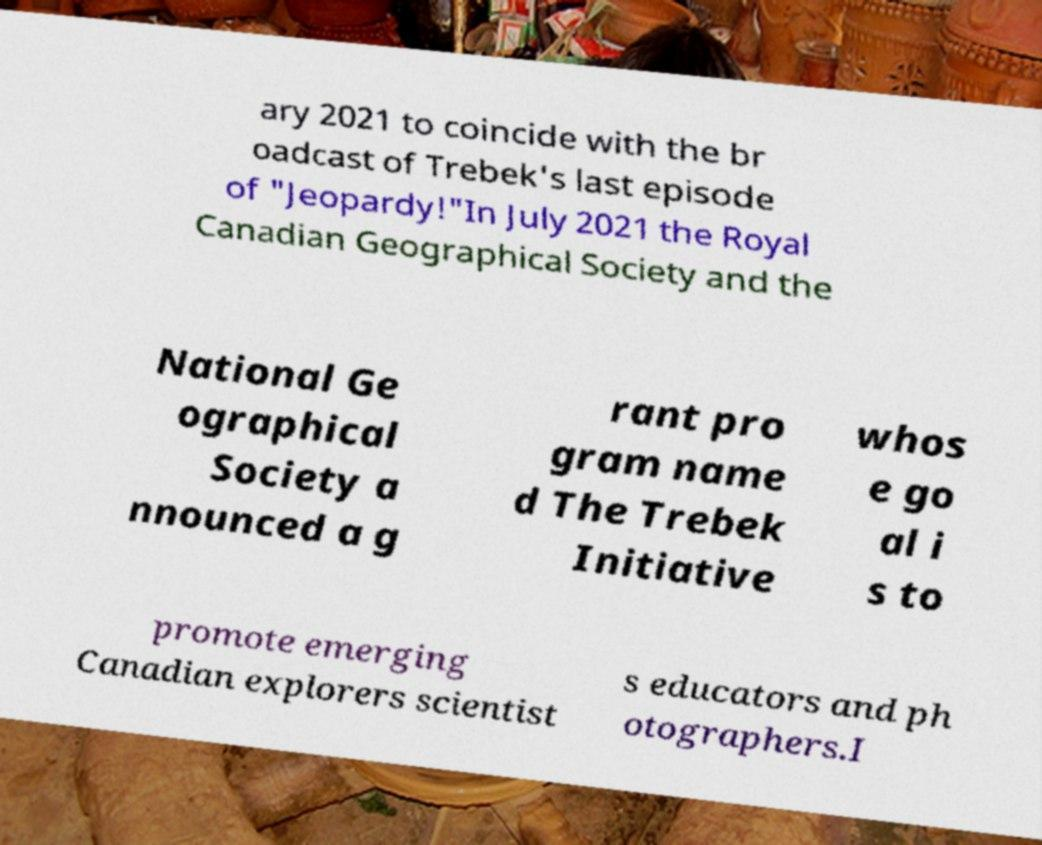Please identify and transcribe the text found in this image. ary 2021 to coincide with the br oadcast of Trebek's last episode of "Jeopardy!"In July 2021 the Royal Canadian Geographical Society and the National Ge ographical Society a nnounced a g rant pro gram name d The Trebek Initiative whos e go al i s to promote emerging Canadian explorers scientist s educators and ph otographers.I 